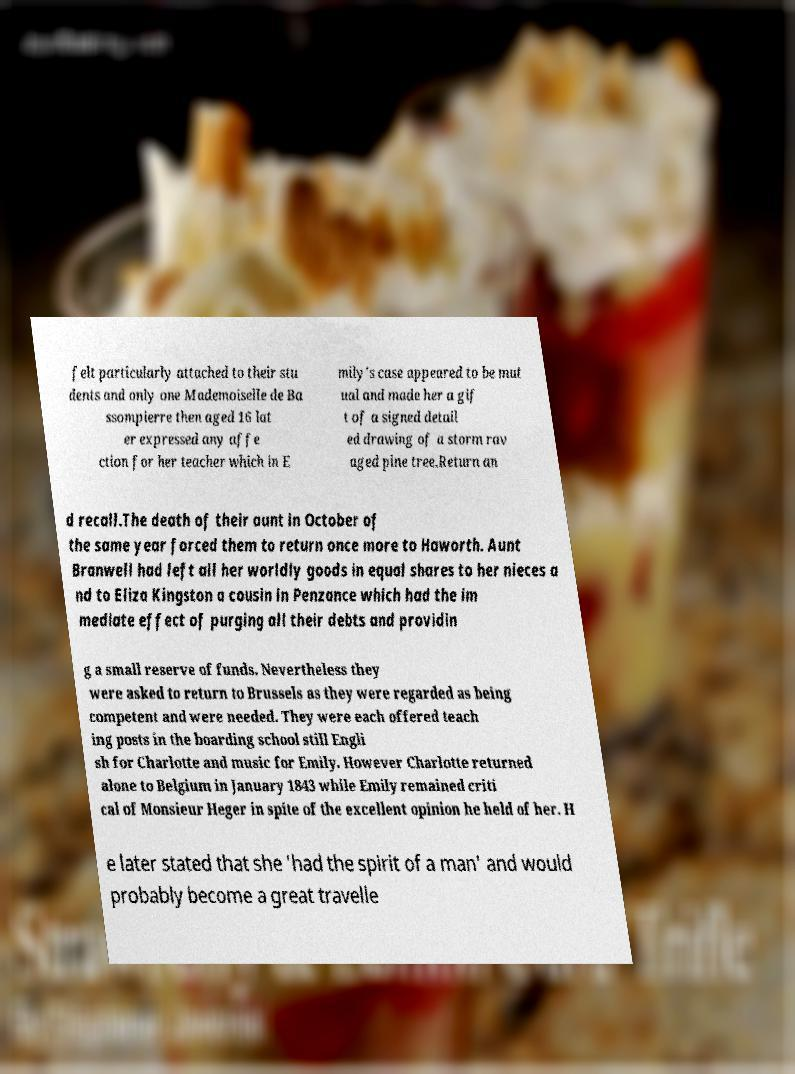Please read and relay the text visible in this image. What does it say? felt particularly attached to their stu dents and only one Mademoiselle de Ba ssompierre then aged 16 lat er expressed any affe ction for her teacher which in E mily's case appeared to be mut ual and made her a gif t of a signed detail ed drawing of a storm rav aged pine tree.Return an d recall.The death of their aunt in October of the same year forced them to return once more to Haworth. Aunt Branwell had left all her worldly goods in equal shares to her nieces a nd to Eliza Kingston a cousin in Penzance which had the im mediate effect of purging all their debts and providin g a small reserve of funds. Nevertheless they were asked to return to Brussels as they were regarded as being competent and were needed. They were each offered teach ing posts in the boarding school still Engli sh for Charlotte and music for Emily. However Charlotte returned alone to Belgium in January 1843 while Emily remained criti cal of Monsieur Heger in spite of the excellent opinion he held of her. H e later stated that she 'had the spirit of a man' and would probably become a great travelle 